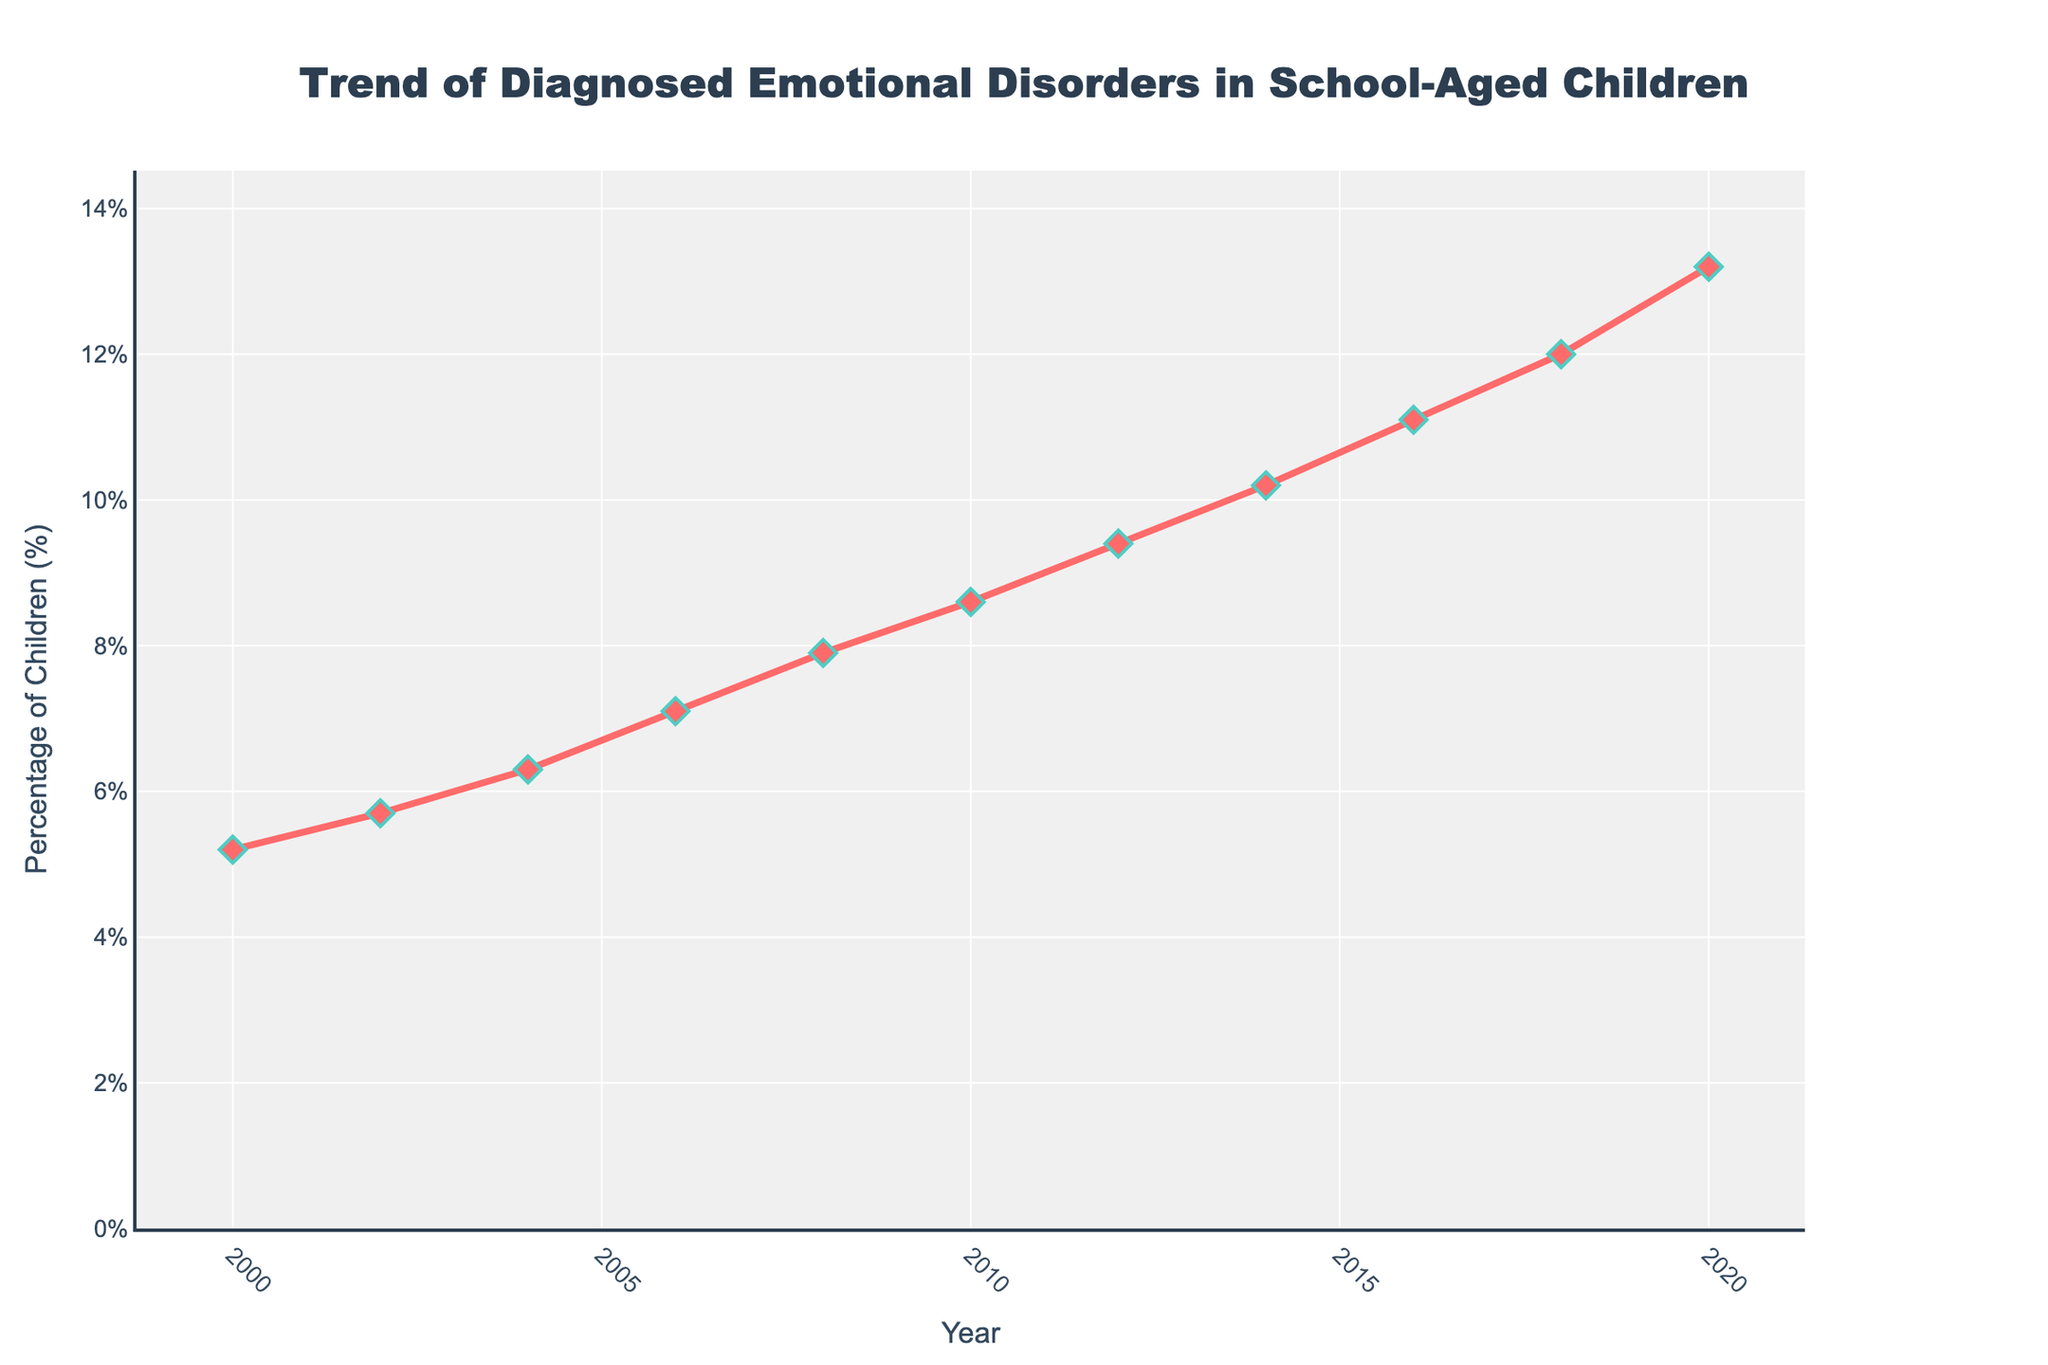What's the trend in the percentage of school-aged children with diagnosed emotional disorders from 2000 to 2020? The line chart displays a clear upward trend over time. Starting in 2000 with 5.2%, it continuously rises each year, reaching 13.2% in 2020.
Answer: Upward trend Which year had the highest percentage of diagnosed emotional disorders? By looking at the peak of the line in the chart, it is evident that 2020 shows the highest point with the percentage reaching 13.2%.
Answer: 2020 In which period did the percentage of diagnosed emotional disorders increase the most rapidly? Comparing the slope of the line segments, the steepest rise appears between 2016 and 2018 when it increased from 11.1% to 12.0%.
Answer: 2016-2018 What is the difference in the percentage of diagnosed emotional disorders between 2000 and 2020? The percentage in 2020 (13.2%) minus the percentage in 2000 (5.2%) results in a difference of 13.2 - 5.2 = 8.0%.
Answer: 8.0% What is the average percentage of diagnosed emotional disorders over the two decades? Sum the percentages from each year and divide by the number of years: (5.2 + 5.7 + 6.3 + 7.1 + 7.9 + 8.6 + 9.4 + 10.2 + 11.1 + 12.0 + 13.2) / 11 = 96.7 / 11 = 8.79%.
Answer: 8.79% How does the percentage in 2010 compare to that in 2012? In 2010, the percentage was 8.6%, and in 2012, it was 9.4%. Comparing these values shows an increase of 9.4 - 8.6 = 0.8%.
Answer: 2012 is 0.8% higher What visual attributes make the 2018 data point stand out on the chart? The 2018 data point is marked by a diamond-shaped marker, larger size (size = 12), and a contrasting line and marker color combination (red with teal outline).
Answer: Unique marker and colors Between which consecutive years is the growth in percentage slower: 2002-2004 or 2004-2006? Calculate the differences: 2004 (6.3%) - 2002 (5.7%) = 0.6% and 2006 (7.1%) - 2004 (6.3%) = 0.8%. The increase from 2002 to 2004 is slower.
Answer: 2002-2004 What is the percentage increase from 2006 to 2020? Percentage in 2020 (13.2%) minus percentage in 2006 (7.1%) is 13.2 - 7.1 = 6.1%, representing the increase.
Answer: 6.1% 